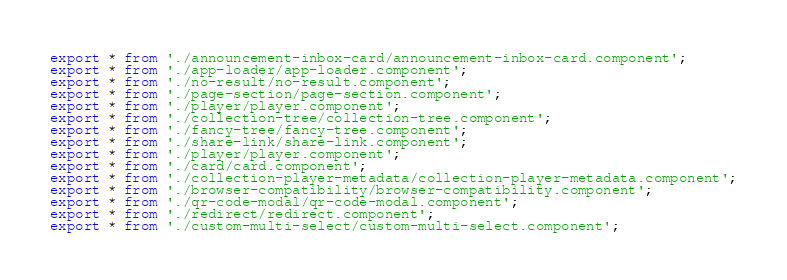<code> <loc_0><loc_0><loc_500><loc_500><_TypeScript_>export * from './announcement-inbox-card/announcement-inbox-card.component';
export * from './app-loader/app-loader.component';
export * from './no-result/no-result.component';
export * from './page-section/page-section.component';
export * from './player/player.component';
export * from './collection-tree/collection-tree.component';
export * from './fancy-tree/fancy-tree.component';
export * from './share-link/share-link.component';
export * from './player/player.component';
export * from './card/card.component';
export * from './collection-player-metadata/collection-player-metadata.component';
export * from './browser-compatibility/browser-compatibility.component';
export * from './qr-code-modal/qr-code-modal.component';
export * from './redirect/redirect.component';
export * from './custom-multi-select/custom-multi-select.component';
</code> 